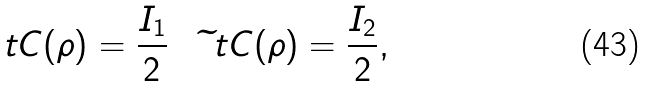Convert formula to latex. <formula><loc_0><loc_0><loc_500><loc_500>\ t C ( \rho ) = \frac { I _ { 1 } } 2 \quad \widetilde { \ } t C ( \rho ) = \frac { I _ { 2 } } 2 ,</formula> 